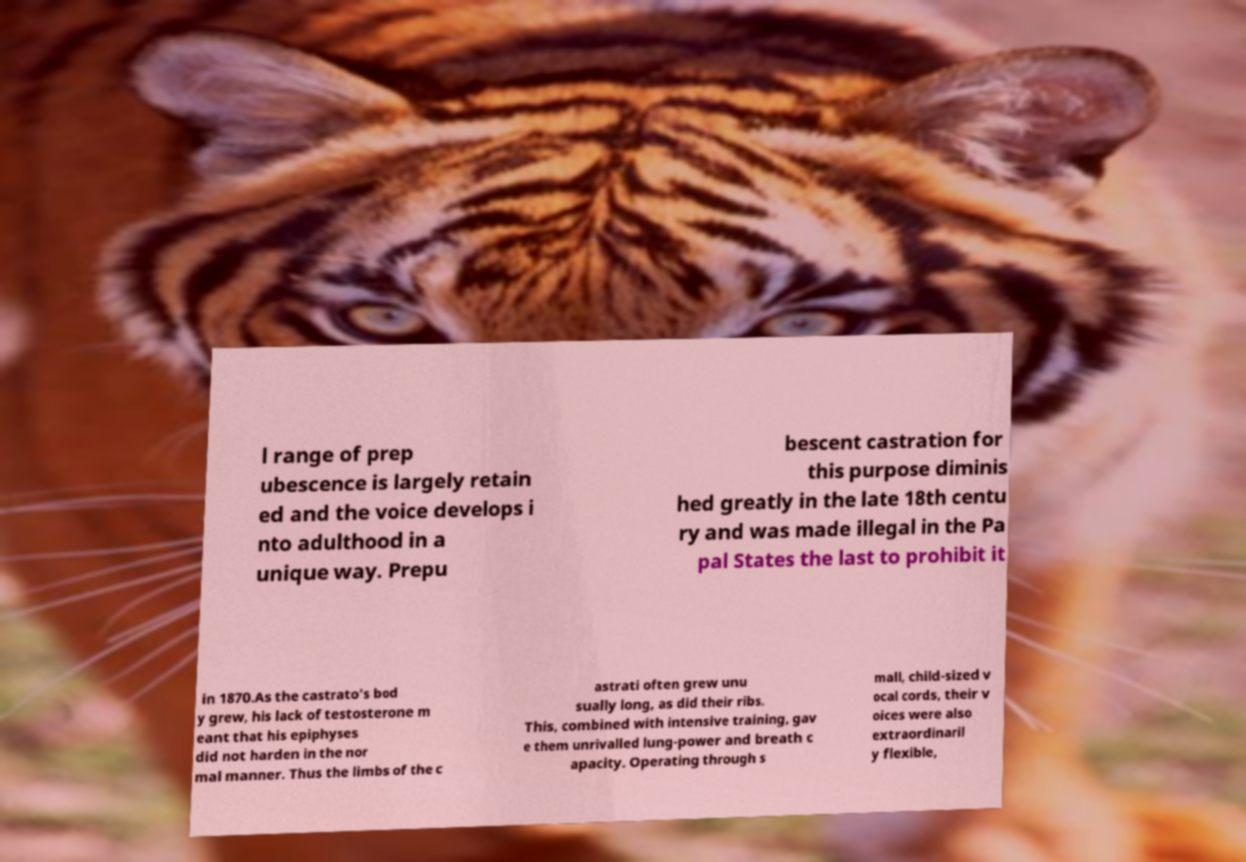Please identify and transcribe the text found in this image. l range of prep ubescence is largely retain ed and the voice develops i nto adulthood in a unique way. Prepu bescent castration for this purpose diminis hed greatly in the late 18th centu ry and was made illegal in the Pa pal States the last to prohibit it in 1870.As the castrato's bod y grew, his lack of testosterone m eant that his epiphyses did not harden in the nor mal manner. Thus the limbs of the c astrati often grew unu sually long, as did their ribs. This, combined with intensive training, gav e them unrivalled lung-power and breath c apacity. Operating through s mall, child-sized v ocal cords, their v oices were also extraordinaril y flexible, 